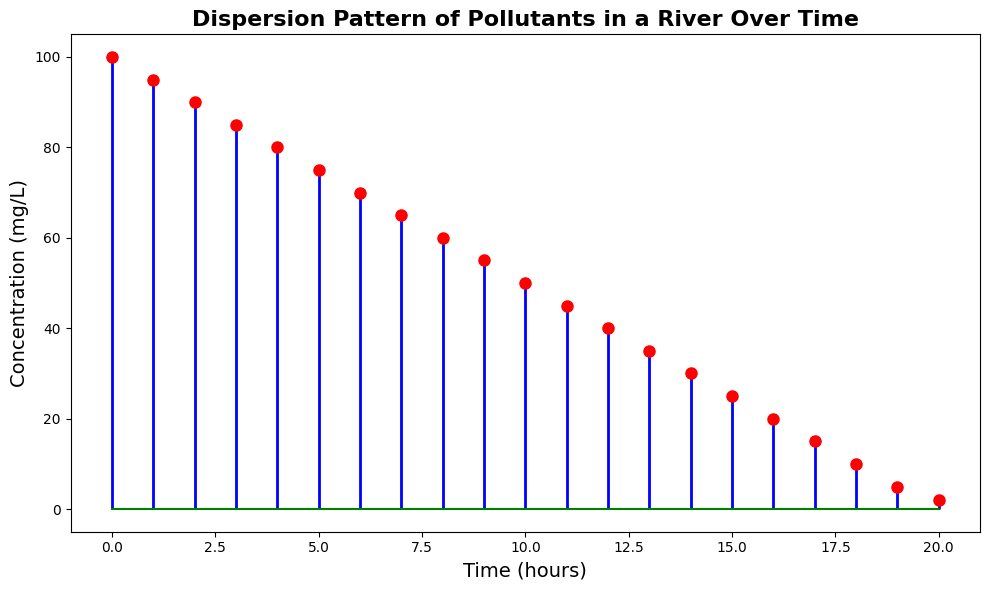What is the concentration of pollutants at the start (Time = 0 hours)? By looking at the first point on the plot, we can see the concentration value at Time = 0 hours. The concentration is marked by a red dot at the far left.
Answer: 100 mg/L Between which two hours does the concentration drop from 70 mg/L to 65 mg/L? By tracing the points on the plot, we can see that the concentration is 70 mg/L at Time = 6 hours and 65 mg/L at Time = 7 hours, indicating these two points.
Answer: Between 6 and 7 hours What is the total drop in concentration from the start (Time = 0 hours) to the end (Time = 20 hours)? The initial concentration at Time = 0 hours is 100 mg/L, and the concentration at Time = 20 hours is 2 mg/L. The total drop is calculated by subtracting the final concentration from the initial concentration (100 - 2).
Answer: 98 mg/L At what time does the concentration reach half of its original value? The original concentration is 100 mg/L. Half of this value is 50 mg/L. By following the plot, we see that the concentration reaches 50 mg/L at Time = 10 hours.
Answer: 10 hours Is the concentration decrease linear over time? By observing the spacing and positioning of the points on the plot, which uniformly decrease, we can infer that the concentration decrease appears to be linear over time.
Answer: Yes How many hours does it take for the concentration to drop from 90 mg/L to 40 mg/L? The concentration is 90 mg/L at Time = 2 hours and drops to 40 mg/L at Time = 12 hours. The number of hours taken is calculated by subtracting these times (12 - 2).
Answer: 10 hours Compare the concentration values at hour 5 and hour 15. Which one is higher? At Time = 5 hours, the concentration is 75 mg/L. At Time = 15 hours, the concentration is 25 mg/L. By comparing these values, we can see that the concentration at hour 5 is higher.
Answer: Hour 5 What is the mean concentration value of the given time points? To find the mean of the concentration, sum all concentration values and divide by the number of time points: (100 + 95 + 90 + ... + 2) / 21 = 50 mg/L. This involves summing the 21 values and dividing by 21.
Answer: 50 mg/L How long does it take for the concentration to drop below 10 mg/L? Following the plot, the concentration level drops below 10 mg/L after Time = 18 hours.
Answer: 18 hours 